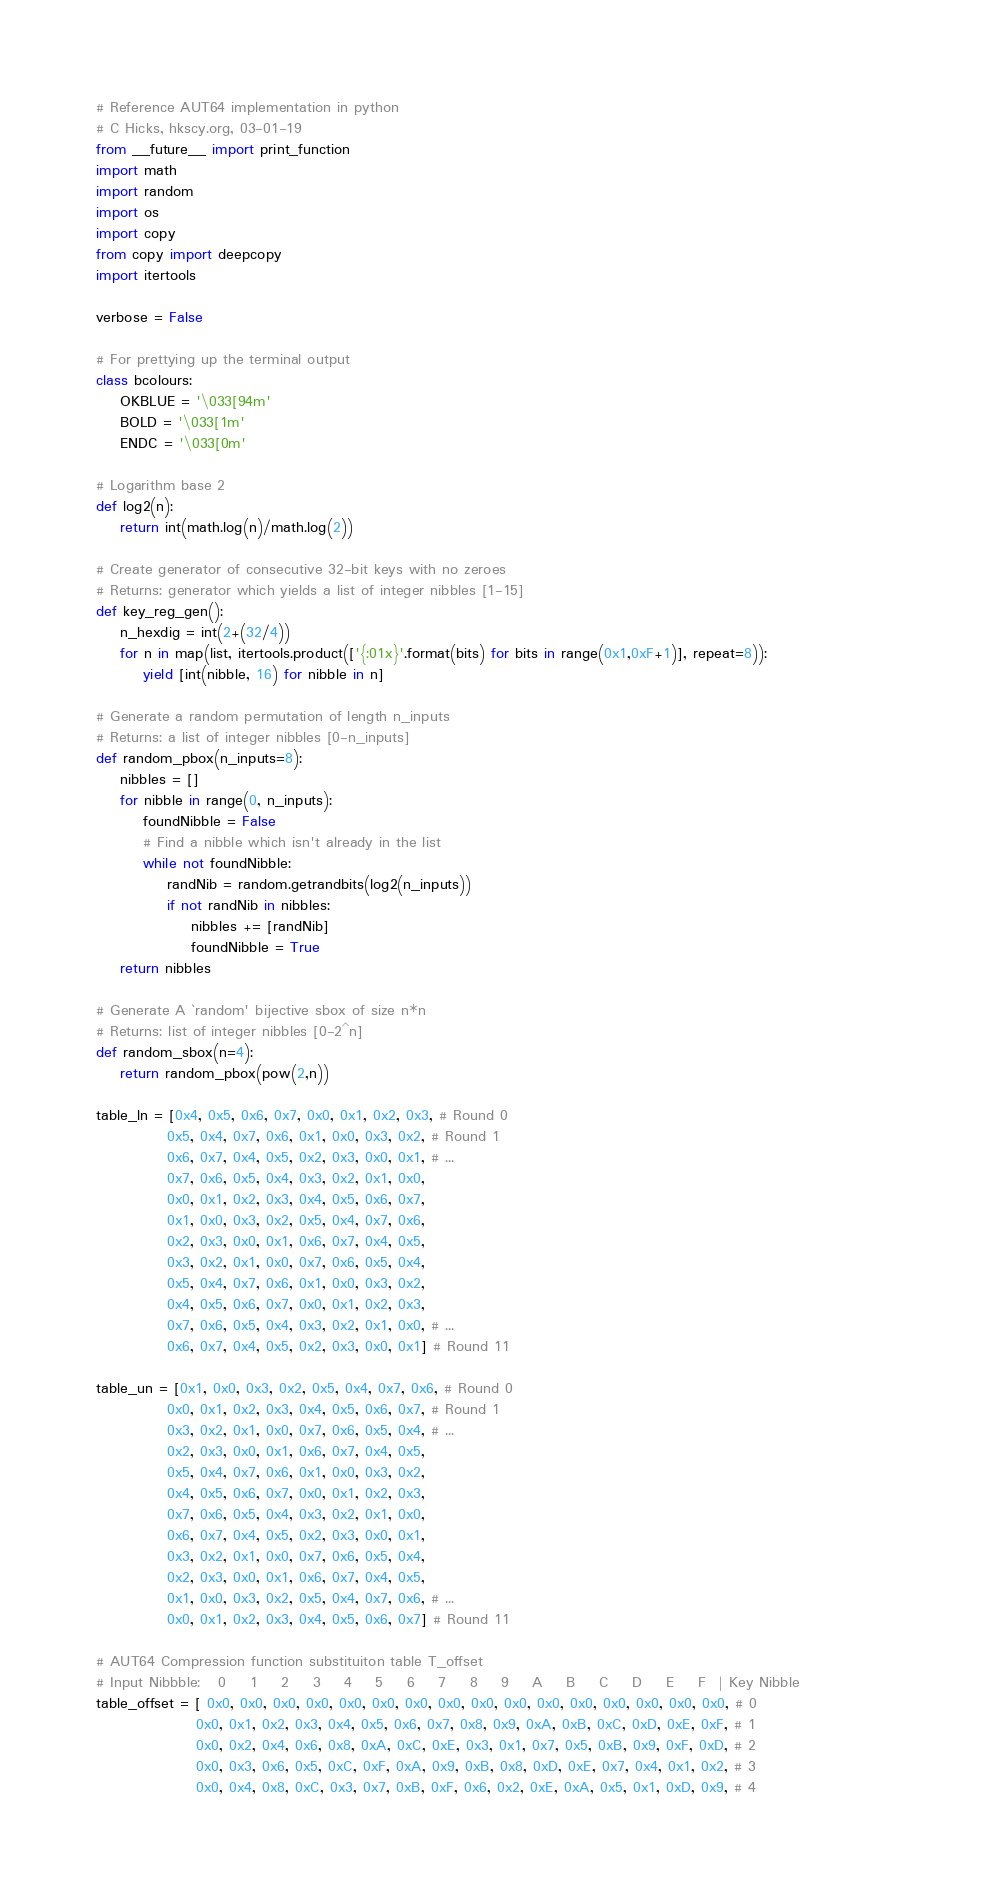<code> <loc_0><loc_0><loc_500><loc_500><_Python_># Reference AUT64 implementation in python
# C Hicks, hkscy.org, 03-01-19
from __future__ import print_function
import math
import random
import os
import copy
from copy import deepcopy
import itertools

verbose = False

# For prettying up the terminal output
class bcolours:
    OKBLUE = '\033[94m'
    BOLD = '\033[1m'
    ENDC = '\033[0m'

# Logarithm base 2
def log2(n):
    return int(math.log(n)/math.log(2))

# Create generator of consecutive 32-bit keys with no zeroes
# Returns: generator which yields a list of integer nibbles [1-15]    
def key_reg_gen():
    n_hexdig = int(2+(32/4)) 
    for n in map(list, itertools.product(['{:01x}'.format(bits) for bits in range(0x1,0xF+1)], repeat=8)):
        yield [int(nibble, 16) for nibble in n]

# Generate a random permutation of length n_inputs
# Returns: a list of integer nibbles [0-n_inputs]
def random_pbox(n_inputs=8):
    nibbles = []
    for nibble in range(0, n_inputs):
        foundNibble = False
        # Find a nibble which isn't already in the list
        while not foundNibble:
            randNib = random.getrandbits(log2(n_inputs))
            if not randNib in nibbles:
                nibbles += [randNib]
                foundNibble = True
    return nibbles        

# Generate A `random' bijective sbox of size n*n
# Returns: list of integer nibbles [0-2^n]
def random_sbox(n=4):
    return random_pbox(pow(2,n))

table_ln = [0x4, 0x5, 0x6, 0x7, 0x0, 0x1, 0x2, 0x3, # Round 0
            0x5, 0x4, 0x7, 0x6, 0x1, 0x0, 0x3, 0x2, # Round 1
            0x6, 0x7, 0x4, 0x5, 0x2, 0x3, 0x0, 0x1, # ...
            0x7, 0x6, 0x5, 0x4, 0x3, 0x2, 0x1, 0x0, 
            0x0, 0x1, 0x2, 0x3, 0x4, 0x5, 0x6, 0x7,
            0x1, 0x0, 0x3, 0x2, 0x5, 0x4, 0x7, 0x6,
            0x2, 0x3, 0x0, 0x1, 0x6, 0x7, 0x4, 0x5,
            0x3, 0x2, 0x1, 0x0, 0x7, 0x6, 0x5, 0x4,
            0x5, 0x4, 0x7, 0x6, 0x1, 0x0, 0x3, 0x2,
            0x4, 0x5, 0x6, 0x7, 0x0, 0x1, 0x2, 0x3,
            0x7, 0x6, 0x5, 0x4, 0x3, 0x2, 0x1, 0x0, # ...
            0x6, 0x7, 0x4, 0x5, 0x2, 0x3, 0x0, 0x1] # Round 11
            
table_un = [0x1, 0x0, 0x3, 0x2, 0x5, 0x4, 0x7, 0x6, # Round 0
            0x0, 0x1, 0x2, 0x3, 0x4, 0x5, 0x6, 0x7, # Round 1
            0x3, 0x2, 0x1, 0x0, 0x7, 0x6, 0x5, 0x4, # ...
            0x2, 0x3, 0x0, 0x1, 0x6, 0x7, 0x4, 0x5, 
            0x5, 0x4, 0x7, 0x6, 0x1, 0x0, 0x3, 0x2, 
            0x4, 0x5, 0x6, 0x7, 0x0, 0x1, 0x2, 0x3, 
            0x7, 0x6, 0x5, 0x4, 0x3, 0x2, 0x1, 0x0, 
            0x6, 0x7, 0x4, 0x5, 0x2, 0x3, 0x0, 0x1, 
            0x3, 0x2, 0x1, 0x0, 0x7, 0x6, 0x5, 0x4,
            0x2, 0x3, 0x0, 0x1, 0x6, 0x7, 0x4, 0x5, 
            0x1, 0x0, 0x3, 0x2, 0x5, 0x4, 0x7, 0x6, # ...
            0x0, 0x1, 0x2, 0x3, 0x4, 0x5, 0x6, 0x7] # Round 11

# AUT64 Compression function substituiton table T_offset         
# Input Nibbble:   0    1    2    3    4    5    6    7    8    9    A    B    C    D    E    F  | Key Nibble               
table_offset = [ 0x0, 0x0, 0x0, 0x0, 0x0, 0x0, 0x0, 0x0, 0x0, 0x0, 0x0, 0x0, 0x0, 0x0, 0x0, 0x0, # 0
                 0x0, 0x1, 0x2, 0x3, 0x4, 0x5, 0x6, 0x7, 0x8, 0x9, 0xA, 0xB, 0xC, 0xD, 0xE, 0xF, # 1
                 0x0, 0x2, 0x4, 0x6, 0x8, 0xA, 0xC, 0xE, 0x3, 0x1, 0x7, 0x5, 0xB, 0x9, 0xF, 0xD, # 2
                 0x0, 0x3, 0x6, 0x5, 0xC, 0xF, 0xA, 0x9, 0xB, 0x8, 0xD, 0xE, 0x7, 0x4, 0x1, 0x2, # 3
                 0x0, 0x4, 0x8, 0xC, 0x3, 0x7, 0xB, 0xF, 0x6, 0x2, 0xE, 0xA, 0x5, 0x1, 0xD, 0x9, # 4</code> 